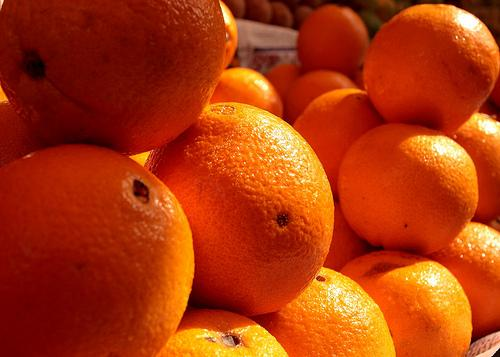What fruit is in the picture?

Choices:
A) mangos
B) apples
C) peaches
D) oranges oranges 